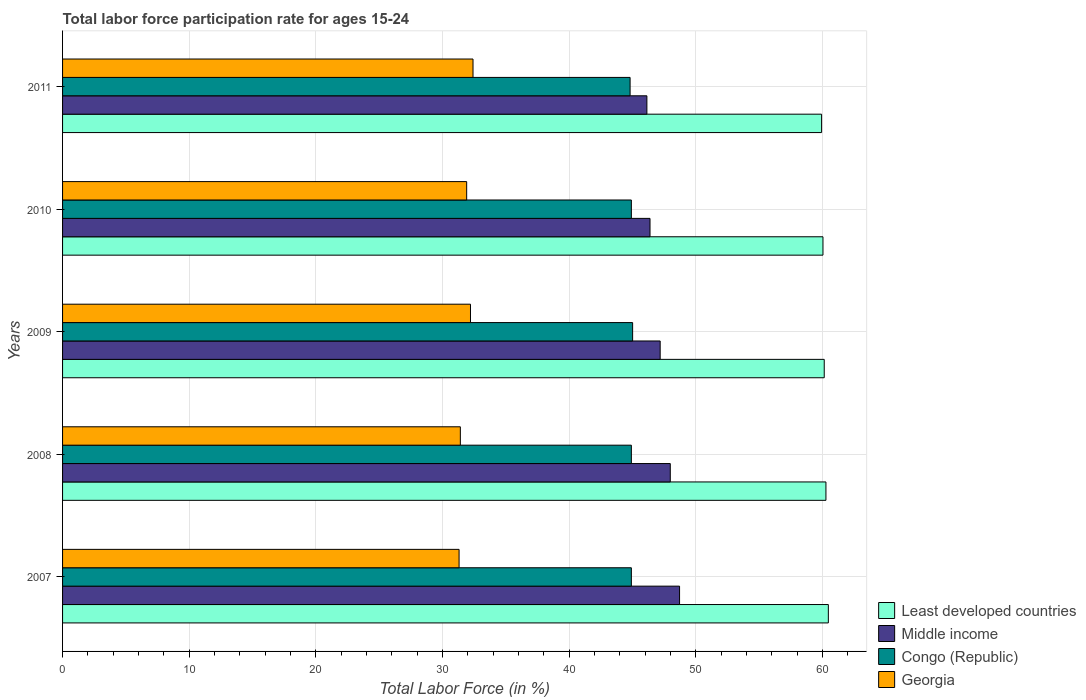How many different coloured bars are there?
Provide a succinct answer. 4. Are the number of bars on each tick of the Y-axis equal?
Give a very brief answer. Yes. How many bars are there on the 3rd tick from the bottom?
Offer a very short reply. 4. What is the label of the 4th group of bars from the top?
Offer a very short reply. 2008. In how many cases, is the number of bars for a given year not equal to the number of legend labels?
Provide a short and direct response. 0. What is the labor force participation rate in Georgia in 2010?
Give a very brief answer. 31.9. Across all years, what is the maximum labor force participation rate in Least developed countries?
Your answer should be very brief. 60.45. Across all years, what is the minimum labor force participation rate in Georgia?
Provide a succinct answer. 31.3. In which year was the labor force participation rate in Congo (Republic) minimum?
Make the answer very short. 2011. What is the total labor force participation rate in Congo (Republic) in the graph?
Give a very brief answer. 224.5. What is the difference between the labor force participation rate in Least developed countries in 2007 and that in 2008?
Offer a very short reply. 0.19. What is the difference between the labor force participation rate in Congo (Republic) in 2009 and the labor force participation rate in Middle income in 2008?
Offer a very short reply. -2.97. What is the average labor force participation rate in Georgia per year?
Ensure brevity in your answer.  31.84. In the year 2009, what is the difference between the labor force participation rate in Middle income and labor force participation rate in Congo (Republic)?
Your answer should be very brief. 2.17. What is the ratio of the labor force participation rate in Congo (Republic) in 2007 to that in 2008?
Provide a short and direct response. 1. Is the difference between the labor force participation rate in Middle income in 2008 and 2011 greater than the difference between the labor force participation rate in Congo (Republic) in 2008 and 2011?
Offer a terse response. Yes. What is the difference between the highest and the second highest labor force participation rate in Congo (Republic)?
Your response must be concise. 0.1. What is the difference between the highest and the lowest labor force participation rate in Least developed countries?
Give a very brief answer. 0.53. Is the sum of the labor force participation rate in Middle income in 2007 and 2008 greater than the maximum labor force participation rate in Georgia across all years?
Offer a terse response. Yes. Is it the case that in every year, the sum of the labor force participation rate in Least developed countries and labor force participation rate in Congo (Republic) is greater than the sum of labor force participation rate in Georgia and labor force participation rate in Middle income?
Ensure brevity in your answer.  Yes. What does the 3rd bar from the top in 2007 represents?
Ensure brevity in your answer.  Middle income. What does the 1st bar from the bottom in 2008 represents?
Your response must be concise. Least developed countries. How many bars are there?
Offer a terse response. 20. Are all the bars in the graph horizontal?
Give a very brief answer. Yes. What is the difference between two consecutive major ticks on the X-axis?
Provide a short and direct response. 10. Does the graph contain any zero values?
Make the answer very short. No. Does the graph contain grids?
Give a very brief answer. Yes. How are the legend labels stacked?
Ensure brevity in your answer.  Vertical. What is the title of the graph?
Your answer should be compact. Total labor force participation rate for ages 15-24. What is the label or title of the X-axis?
Provide a short and direct response. Total Labor Force (in %). What is the Total Labor Force (in %) in Least developed countries in 2007?
Provide a succinct answer. 60.45. What is the Total Labor Force (in %) of Middle income in 2007?
Provide a succinct answer. 48.7. What is the Total Labor Force (in %) of Congo (Republic) in 2007?
Your response must be concise. 44.9. What is the Total Labor Force (in %) of Georgia in 2007?
Offer a very short reply. 31.3. What is the Total Labor Force (in %) in Least developed countries in 2008?
Provide a succinct answer. 60.26. What is the Total Labor Force (in %) of Middle income in 2008?
Your response must be concise. 47.97. What is the Total Labor Force (in %) in Congo (Republic) in 2008?
Your answer should be very brief. 44.9. What is the Total Labor Force (in %) of Georgia in 2008?
Provide a short and direct response. 31.4. What is the Total Labor Force (in %) in Least developed countries in 2009?
Your response must be concise. 60.13. What is the Total Labor Force (in %) in Middle income in 2009?
Offer a very short reply. 47.17. What is the Total Labor Force (in %) in Congo (Republic) in 2009?
Your answer should be compact. 45. What is the Total Labor Force (in %) in Georgia in 2009?
Make the answer very short. 32.2. What is the Total Labor Force (in %) of Least developed countries in 2010?
Provide a succinct answer. 60.02. What is the Total Labor Force (in %) in Middle income in 2010?
Your answer should be very brief. 46.37. What is the Total Labor Force (in %) of Congo (Republic) in 2010?
Provide a short and direct response. 44.9. What is the Total Labor Force (in %) of Georgia in 2010?
Your answer should be very brief. 31.9. What is the Total Labor Force (in %) in Least developed countries in 2011?
Your answer should be very brief. 59.92. What is the Total Labor Force (in %) in Middle income in 2011?
Keep it short and to the point. 46.13. What is the Total Labor Force (in %) in Congo (Republic) in 2011?
Your answer should be very brief. 44.8. What is the Total Labor Force (in %) in Georgia in 2011?
Give a very brief answer. 32.4. Across all years, what is the maximum Total Labor Force (in %) of Least developed countries?
Make the answer very short. 60.45. Across all years, what is the maximum Total Labor Force (in %) of Middle income?
Your answer should be very brief. 48.7. Across all years, what is the maximum Total Labor Force (in %) of Congo (Republic)?
Keep it short and to the point. 45. Across all years, what is the maximum Total Labor Force (in %) in Georgia?
Provide a short and direct response. 32.4. Across all years, what is the minimum Total Labor Force (in %) in Least developed countries?
Keep it short and to the point. 59.92. Across all years, what is the minimum Total Labor Force (in %) of Middle income?
Your answer should be compact. 46.13. Across all years, what is the minimum Total Labor Force (in %) in Congo (Republic)?
Ensure brevity in your answer.  44.8. Across all years, what is the minimum Total Labor Force (in %) of Georgia?
Provide a short and direct response. 31.3. What is the total Total Labor Force (in %) of Least developed countries in the graph?
Ensure brevity in your answer.  300.77. What is the total Total Labor Force (in %) in Middle income in the graph?
Ensure brevity in your answer.  236.35. What is the total Total Labor Force (in %) of Congo (Republic) in the graph?
Offer a very short reply. 224.5. What is the total Total Labor Force (in %) in Georgia in the graph?
Offer a terse response. 159.2. What is the difference between the Total Labor Force (in %) in Least developed countries in 2007 and that in 2008?
Your answer should be compact. 0.19. What is the difference between the Total Labor Force (in %) of Middle income in 2007 and that in 2008?
Your response must be concise. 0.73. What is the difference between the Total Labor Force (in %) in Congo (Republic) in 2007 and that in 2008?
Offer a terse response. 0. What is the difference between the Total Labor Force (in %) in Georgia in 2007 and that in 2008?
Provide a succinct answer. -0.1. What is the difference between the Total Labor Force (in %) in Least developed countries in 2007 and that in 2009?
Provide a succinct answer. 0.32. What is the difference between the Total Labor Force (in %) of Middle income in 2007 and that in 2009?
Make the answer very short. 1.53. What is the difference between the Total Labor Force (in %) of Least developed countries in 2007 and that in 2010?
Offer a terse response. 0.42. What is the difference between the Total Labor Force (in %) of Middle income in 2007 and that in 2010?
Your answer should be very brief. 2.33. What is the difference between the Total Labor Force (in %) of Congo (Republic) in 2007 and that in 2010?
Make the answer very short. 0. What is the difference between the Total Labor Force (in %) of Least developed countries in 2007 and that in 2011?
Make the answer very short. 0.53. What is the difference between the Total Labor Force (in %) of Middle income in 2007 and that in 2011?
Offer a very short reply. 2.58. What is the difference between the Total Labor Force (in %) in Least developed countries in 2008 and that in 2009?
Offer a very short reply. 0.13. What is the difference between the Total Labor Force (in %) of Middle income in 2008 and that in 2009?
Provide a short and direct response. 0.8. What is the difference between the Total Labor Force (in %) in Least developed countries in 2008 and that in 2010?
Your answer should be compact. 0.23. What is the difference between the Total Labor Force (in %) in Middle income in 2008 and that in 2010?
Keep it short and to the point. 1.6. What is the difference between the Total Labor Force (in %) in Congo (Republic) in 2008 and that in 2010?
Provide a short and direct response. 0. What is the difference between the Total Labor Force (in %) of Least developed countries in 2008 and that in 2011?
Provide a succinct answer. 0.34. What is the difference between the Total Labor Force (in %) in Middle income in 2008 and that in 2011?
Your response must be concise. 1.85. What is the difference between the Total Labor Force (in %) of Congo (Republic) in 2008 and that in 2011?
Keep it short and to the point. 0.1. What is the difference between the Total Labor Force (in %) in Georgia in 2008 and that in 2011?
Offer a very short reply. -1. What is the difference between the Total Labor Force (in %) of Least developed countries in 2009 and that in 2010?
Make the answer very short. 0.1. What is the difference between the Total Labor Force (in %) of Middle income in 2009 and that in 2010?
Ensure brevity in your answer.  0.8. What is the difference between the Total Labor Force (in %) in Congo (Republic) in 2009 and that in 2010?
Your answer should be very brief. 0.1. What is the difference between the Total Labor Force (in %) of Georgia in 2009 and that in 2010?
Your answer should be compact. 0.3. What is the difference between the Total Labor Force (in %) of Least developed countries in 2009 and that in 2011?
Make the answer very short. 0.21. What is the difference between the Total Labor Force (in %) in Middle income in 2009 and that in 2011?
Offer a very short reply. 1.05. What is the difference between the Total Labor Force (in %) in Congo (Republic) in 2009 and that in 2011?
Keep it short and to the point. 0.2. What is the difference between the Total Labor Force (in %) in Georgia in 2009 and that in 2011?
Provide a short and direct response. -0.2. What is the difference between the Total Labor Force (in %) of Least developed countries in 2010 and that in 2011?
Give a very brief answer. 0.11. What is the difference between the Total Labor Force (in %) in Middle income in 2010 and that in 2011?
Offer a terse response. 0.25. What is the difference between the Total Labor Force (in %) in Least developed countries in 2007 and the Total Labor Force (in %) in Middle income in 2008?
Ensure brevity in your answer.  12.48. What is the difference between the Total Labor Force (in %) of Least developed countries in 2007 and the Total Labor Force (in %) of Congo (Republic) in 2008?
Give a very brief answer. 15.55. What is the difference between the Total Labor Force (in %) of Least developed countries in 2007 and the Total Labor Force (in %) of Georgia in 2008?
Your answer should be very brief. 29.05. What is the difference between the Total Labor Force (in %) of Middle income in 2007 and the Total Labor Force (in %) of Congo (Republic) in 2008?
Offer a very short reply. 3.8. What is the difference between the Total Labor Force (in %) in Middle income in 2007 and the Total Labor Force (in %) in Georgia in 2008?
Your response must be concise. 17.3. What is the difference between the Total Labor Force (in %) in Least developed countries in 2007 and the Total Labor Force (in %) in Middle income in 2009?
Ensure brevity in your answer.  13.28. What is the difference between the Total Labor Force (in %) in Least developed countries in 2007 and the Total Labor Force (in %) in Congo (Republic) in 2009?
Provide a succinct answer. 15.45. What is the difference between the Total Labor Force (in %) in Least developed countries in 2007 and the Total Labor Force (in %) in Georgia in 2009?
Your answer should be compact. 28.25. What is the difference between the Total Labor Force (in %) of Middle income in 2007 and the Total Labor Force (in %) of Congo (Republic) in 2009?
Keep it short and to the point. 3.7. What is the difference between the Total Labor Force (in %) of Middle income in 2007 and the Total Labor Force (in %) of Georgia in 2009?
Your answer should be very brief. 16.5. What is the difference between the Total Labor Force (in %) of Congo (Republic) in 2007 and the Total Labor Force (in %) of Georgia in 2009?
Provide a succinct answer. 12.7. What is the difference between the Total Labor Force (in %) in Least developed countries in 2007 and the Total Labor Force (in %) in Middle income in 2010?
Offer a very short reply. 14.08. What is the difference between the Total Labor Force (in %) in Least developed countries in 2007 and the Total Labor Force (in %) in Congo (Republic) in 2010?
Offer a terse response. 15.55. What is the difference between the Total Labor Force (in %) of Least developed countries in 2007 and the Total Labor Force (in %) of Georgia in 2010?
Your response must be concise. 28.55. What is the difference between the Total Labor Force (in %) of Middle income in 2007 and the Total Labor Force (in %) of Congo (Republic) in 2010?
Offer a terse response. 3.8. What is the difference between the Total Labor Force (in %) in Middle income in 2007 and the Total Labor Force (in %) in Georgia in 2010?
Ensure brevity in your answer.  16.8. What is the difference between the Total Labor Force (in %) in Least developed countries in 2007 and the Total Labor Force (in %) in Middle income in 2011?
Your response must be concise. 14.32. What is the difference between the Total Labor Force (in %) of Least developed countries in 2007 and the Total Labor Force (in %) of Congo (Republic) in 2011?
Provide a short and direct response. 15.65. What is the difference between the Total Labor Force (in %) of Least developed countries in 2007 and the Total Labor Force (in %) of Georgia in 2011?
Make the answer very short. 28.05. What is the difference between the Total Labor Force (in %) in Middle income in 2007 and the Total Labor Force (in %) in Congo (Republic) in 2011?
Provide a short and direct response. 3.9. What is the difference between the Total Labor Force (in %) of Middle income in 2007 and the Total Labor Force (in %) of Georgia in 2011?
Your response must be concise. 16.3. What is the difference between the Total Labor Force (in %) of Congo (Republic) in 2007 and the Total Labor Force (in %) of Georgia in 2011?
Offer a very short reply. 12.5. What is the difference between the Total Labor Force (in %) in Least developed countries in 2008 and the Total Labor Force (in %) in Middle income in 2009?
Give a very brief answer. 13.09. What is the difference between the Total Labor Force (in %) in Least developed countries in 2008 and the Total Labor Force (in %) in Congo (Republic) in 2009?
Provide a succinct answer. 15.26. What is the difference between the Total Labor Force (in %) of Least developed countries in 2008 and the Total Labor Force (in %) of Georgia in 2009?
Your answer should be compact. 28.06. What is the difference between the Total Labor Force (in %) in Middle income in 2008 and the Total Labor Force (in %) in Congo (Republic) in 2009?
Offer a very short reply. 2.97. What is the difference between the Total Labor Force (in %) of Middle income in 2008 and the Total Labor Force (in %) of Georgia in 2009?
Provide a short and direct response. 15.77. What is the difference between the Total Labor Force (in %) in Least developed countries in 2008 and the Total Labor Force (in %) in Middle income in 2010?
Give a very brief answer. 13.89. What is the difference between the Total Labor Force (in %) in Least developed countries in 2008 and the Total Labor Force (in %) in Congo (Republic) in 2010?
Offer a very short reply. 15.36. What is the difference between the Total Labor Force (in %) in Least developed countries in 2008 and the Total Labor Force (in %) in Georgia in 2010?
Your response must be concise. 28.36. What is the difference between the Total Labor Force (in %) of Middle income in 2008 and the Total Labor Force (in %) of Congo (Republic) in 2010?
Ensure brevity in your answer.  3.07. What is the difference between the Total Labor Force (in %) of Middle income in 2008 and the Total Labor Force (in %) of Georgia in 2010?
Your response must be concise. 16.07. What is the difference between the Total Labor Force (in %) of Congo (Republic) in 2008 and the Total Labor Force (in %) of Georgia in 2010?
Make the answer very short. 13. What is the difference between the Total Labor Force (in %) in Least developed countries in 2008 and the Total Labor Force (in %) in Middle income in 2011?
Your response must be concise. 14.13. What is the difference between the Total Labor Force (in %) of Least developed countries in 2008 and the Total Labor Force (in %) of Congo (Republic) in 2011?
Your response must be concise. 15.46. What is the difference between the Total Labor Force (in %) of Least developed countries in 2008 and the Total Labor Force (in %) of Georgia in 2011?
Keep it short and to the point. 27.86. What is the difference between the Total Labor Force (in %) of Middle income in 2008 and the Total Labor Force (in %) of Congo (Republic) in 2011?
Provide a short and direct response. 3.17. What is the difference between the Total Labor Force (in %) of Middle income in 2008 and the Total Labor Force (in %) of Georgia in 2011?
Ensure brevity in your answer.  15.57. What is the difference between the Total Labor Force (in %) of Least developed countries in 2009 and the Total Labor Force (in %) of Middle income in 2010?
Make the answer very short. 13.75. What is the difference between the Total Labor Force (in %) of Least developed countries in 2009 and the Total Labor Force (in %) of Congo (Republic) in 2010?
Provide a short and direct response. 15.23. What is the difference between the Total Labor Force (in %) of Least developed countries in 2009 and the Total Labor Force (in %) of Georgia in 2010?
Make the answer very short. 28.23. What is the difference between the Total Labor Force (in %) of Middle income in 2009 and the Total Labor Force (in %) of Congo (Republic) in 2010?
Your response must be concise. 2.27. What is the difference between the Total Labor Force (in %) in Middle income in 2009 and the Total Labor Force (in %) in Georgia in 2010?
Ensure brevity in your answer.  15.27. What is the difference between the Total Labor Force (in %) in Least developed countries in 2009 and the Total Labor Force (in %) in Middle income in 2011?
Provide a short and direct response. 14. What is the difference between the Total Labor Force (in %) in Least developed countries in 2009 and the Total Labor Force (in %) in Congo (Republic) in 2011?
Provide a succinct answer. 15.33. What is the difference between the Total Labor Force (in %) in Least developed countries in 2009 and the Total Labor Force (in %) in Georgia in 2011?
Offer a very short reply. 27.73. What is the difference between the Total Labor Force (in %) in Middle income in 2009 and the Total Labor Force (in %) in Congo (Republic) in 2011?
Your answer should be compact. 2.37. What is the difference between the Total Labor Force (in %) of Middle income in 2009 and the Total Labor Force (in %) of Georgia in 2011?
Give a very brief answer. 14.77. What is the difference between the Total Labor Force (in %) in Least developed countries in 2010 and the Total Labor Force (in %) in Middle income in 2011?
Your response must be concise. 13.9. What is the difference between the Total Labor Force (in %) of Least developed countries in 2010 and the Total Labor Force (in %) of Congo (Republic) in 2011?
Your answer should be very brief. 15.22. What is the difference between the Total Labor Force (in %) of Least developed countries in 2010 and the Total Labor Force (in %) of Georgia in 2011?
Offer a terse response. 27.62. What is the difference between the Total Labor Force (in %) in Middle income in 2010 and the Total Labor Force (in %) in Congo (Republic) in 2011?
Make the answer very short. 1.57. What is the difference between the Total Labor Force (in %) of Middle income in 2010 and the Total Labor Force (in %) of Georgia in 2011?
Keep it short and to the point. 13.97. What is the difference between the Total Labor Force (in %) in Congo (Republic) in 2010 and the Total Labor Force (in %) in Georgia in 2011?
Give a very brief answer. 12.5. What is the average Total Labor Force (in %) in Least developed countries per year?
Give a very brief answer. 60.15. What is the average Total Labor Force (in %) of Middle income per year?
Your answer should be very brief. 47.27. What is the average Total Labor Force (in %) in Congo (Republic) per year?
Give a very brief answer. 44.9. What is the average Total Labor Force (in %) in Georgia per year?
Your response must be concise. 31.84. In the year 2007, what is the difference between the Total Labor Force (in %) of Least developed countries and Total Labor Force (in %) of Middle income?
Give a very brief answer. 11.75. In the year 2007, what is the difference between the Total Labor Force (in %) in Least developed countries and Total Labor Force (in %) in Congo (Republic)?
Your answer should be compact. 15.55. In the year 2007, what is the difference between the Total Labor Force (in %) of Least developed countries and Total Labor Force (in %) of Georgia?
Your answer should be very brief. 29.15. In the year 2007, what is the difference between the Total Labor Force (in %) of Middle income and Total Labor Force (in %) of Congo (Republic)?
Your answer should be compact. 3.8. In the year 2007, what is the difference between the Total Labor Force (in %) in Middle income and Total Labor Force (in %) in Georgia?
Ensure brevity in your answer.  17.4. In the year 2008, what is the difference between the Total Labor Force (in %) in Least developed countries and Total Labor Force (in %) in Middle income?
Your answer should be compact. 12.29. In the year 2008, what is the difference between the Total Labor Force (in %) of Least developed countries and Total Labor Force (in %) of Congo (Republic)?
Provide a succinct answer. 15.36. In the year 2008, what is the difference between the Total Labor Force (in %) in Least developed countries and Total Labor Force (in %) in Georgia?
Your answer should be very brief. 28.86. In the year 2008, what is the difference between the Total Labor Force (in %) in Middle income and Total Labor Force (in %) in Congo (Republic)?
Give a very brief answer. 3.07. In the year 2008, what is the difference between the Total Labor Force (in %) of Middle income and Total Labor Force (in %) of Georgia?
Offer a terse response. 16.57. In the year 2009, what is the difference between the Total Labor Force (in %) of Least developed countries and Total Labor Force (in %) of Middle income?
Offer a terse response. 12.95. In the year 2009, what is the difference between the Total Labor Force (in %) in Least developed countries and Total Labor Force (in %) in Congo (Republic)?
Keep it short and to the point. 15.13. In the year 2009, what is the difference between the Total Labor Force (in %) in Least developed countries and Total Labor Force (in %) in Georgia?
Ensure brevity in your answer.  27.93. In the year 2009, what is the difference between the Total Labor Force (in %) of Middle income and Total Labor Force (in %) of Congo (Republic)?
Your answer should be compact. 2.17. In the year 2009, what is the difference between the Total Labor Force (in %) in Middle income and Total Labor Force (in %) in Georgia?
Offer a terse response. 14.97. In the year 2009, what is the difference between the Total Labor Force (in %) in Congo (Republic) and Total Labor Force (in %) in Georgia?
Your response must be concise. 12.8. In the year 2010, what is the difference between the Total Labor Force (in %) in Least developed countries and Total Labor Force (in %) in Middle income?
Your answer should be very brief. 13.65. In the year 2010, what is the difference between the Total Labor Force (in %) of Least developed countries and Total Labor Force (in %) of Congo (Republic)?
Give a very brief answer. 15.12. In the year 2010, what is the difference between the Total Labor Force (in %) of Least developed countries and Total Labor Force (in %) of Georgia?
Your answer should be very brief. 28.12. In the year 2010, what is the difference between the Total Labor Force (in %) of Middle income and Total Labor Force (in %) of Congo (Republic)?
Your response must be concise. 1.47. In the year 2010, what is the difference between the Total Labor Force (in %) in Middle income and Total Labor Force (in %) in Georgia?
Make the answer very short. 14.47. In the year 2010, what is the difference between the Total Labor Force (in %) of Congo (Republic) and Total Labor Force (in %) of Georgia?
Ensure brevity in your answer.  13. In the year 2011, what is the difference between the Total Labor Force (in %) of Least developed countries and Total Labor Force (in %) of Middle income?
Ensure brevity in your answer.  13.79. In the year 2011, what is the difference between the Total Labor Force (in %) of Least developed countries and Total Labor Force (in %) of Congo (Republic)?
Offer a terse response. 15.12. In the year 2011, what is the difference between the Total Labor Force (in %) in Least developed countries and Total Labor Force (in %) in Georgia?
Make the answer very short. 27.52. In the year 2011, what is the difference between the Total Labor Force (in %) in Middle income and Total Labor Force (in %) in Congo (Republic)?
Ensure brevity in your answer.  1.33. In the year 2011, what is the difference between the Total Labor Force (in %) in Middle income and Total Labor Force (in %) in Georgia?
Give a very brief answer. 13.73. In the year 2011, what is the difference between the Total Labor Force (in %) of Congo (Republic) and Total Labor Force (in %) of Georgia?
Offer a terse response. 12.4. What is the ratio of the Total Labor Force (in %) in Middle income in 2007 to that in 2008?
Your response must be concise. 1.02. What is the ratio of the Total Labor Force (in %) in Congo (Republic) in 2007 to that in 2008?
Ensure brevity in your answer.  1. What is the ratio of the Total Labor Force (in %) of Georgia in 2007 to that in 2008?
Provide a short and direct response. 1. What is the ratio of the Total Labor Force (in %) of Least developed countries in 2007 to that in 2009?
Offer a very short reply. 1.01. What is the ratio of the Total Labor Force (in %) in Middle income in 2007 to that in 2009?
Your response must be concise. 1.03. What is the ratio of the Total Labor Force (in %) in Least developed countries in 2007 to that in 2010?
Offer a very short reply. 1.01. What is the ratio of the Total Labor Force (in %) of Middle income in 2007 to that in 2010?
Keep it short and to the point. 1.05. What is the ratio of the Total Labor Force (in %) in Georgia in 2007 to that in 2010?
Offer a terse response. 0.98. What is the ratio of the Total Labor Force (in %) in Least developed countries in 2007 to that in 2011?
Ensure brevity in your answer.  1.01. What is the ratio of the Total Labor Force (in %) in Middle income in 2007 to that in 2011?
Give a very brief answer. 1.06. What is the ratio of the Total Labor Force (in %) of Congo (Republic) in 2007 to that in 2011?
Your answer should be very brief. 1. What is the ratio of the Total Labor Force (in %) of Middle income in 2008 to that in 2009?
Provide a short and direct response. 1.02. What is the ratio of the Total Labor Force (in %) in Congo (Republic) in 2008 to that in 2009?
Your response must be concise. 1. What is the ratio of the Total Labor Force (in %) of Georgia in 2008 to that in 2009?
Make the answer very short. 0.98. What is the ratio of the Total Labor Force (in %) in Least developed countries in 2008 to that in 2010?
Provide a short and direct response. 1. What is the ratio of the Total Labor Force (in %) in Middle income in 2008 to that in 2010?
Give a very brief answer. 1.03. What is the ratio of the Total Labor Force (in %) of Congo (Republic) in 2008 to that in 2010?
Provide a short and direct response. 1. What is the ratio of the Total Labor Force (in %) of Georgia in 2008 to that in 2010?
Your answer should be very brief. 0.98. What is the ratio of the Total Labor Force (in %) in Middle income in 2008 to that in 2011?
Give a very brief answer. 1.04. What is the ratio of the Total Labor Force (in %) in Georgia in 2008 to that in 2011?
Your answer should be very brief. 0.97. What is the ratio of the Total Labor Force (in %) in Least developed countries in 2009 to that in 2010?
Give a very brief answer. 1. What is the ratio of the Total Labor Force (in %) in Middle income in 2009 to that in 2010?
Ensure brevity in your answer.  1.02. What is the ratio of the Total Labor Force (in %) of Georgia in 2009 to that in 2010?
Keep it short and to the point. 1.01. What is the ratio of the Total Labor Force (in %) of Middle income in 2009 to that in 2011?
Your answer should be very brief. 1.02. What is the ratio of the Total Labor Force (in %) of Congo (Republic) in 2009 to that in 2011?
Keep it short and to the point. 1. What is the ratio of the Total Labor Force (in %) of Georgia in 2009 to that in 2011?
Provide a succinct answer. 0.99. What is the ratio of the Total Labor Force (in %) in Middle income in 2010 to that in 2011?
Your answer should be compact. 1.01. What is the ratio of the Total Labor Force (in %) in Congo (Republic) in 2010 to that in 2011?
Your response must be concise. 1. What is the ratio of the Total Labor Force (in %) in Georgia in 2010 to that in 2011?
Make the answer very short. 0.98. What is the difference between the highest and the second highest Total Labor Force (in %) in Least developed countries?
Keep it short and to the point. 0.19. What is the difference between the highest and the second highest Total Labor Force (in %) in Middle income?
Ensure brevity in your answer.  0.73. What is the difference between the highest and the second highest Total Labor Force (in %) of Georgia?
Make the answer very short. 0.2. What is the difference between the highest and the lowest Total Labor Force (in %) of Least developed countries?
Ensure brevity in your answer.  0.53. What is the difference between the highest and the lowest Total Labor Force (in %) in Middle income?
Your response must be concise. 2.58. What is the difference between the highest and the lowest Total Labor Force (in %) in Congo (Republic)?
Your response must be concise. 0.2. What is the difference between the highest and the lowest Total Labor Force (in %) in Georgia?
Make the answer very short. 1.1. 